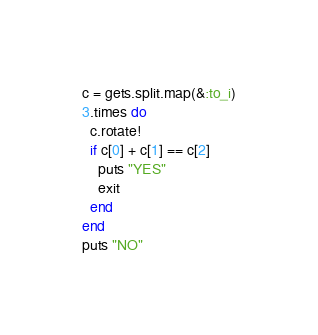Convert code to text. <code><loc_0><loc_0><loc_500><loc_500><_Ruby_>c = gets.split.map(&:to_i)
3.times do
  c.rotate!
  if c[0] + c[1] == c[2]
    puts "YES"
    exit
  end
end
puts "NO"</code> 